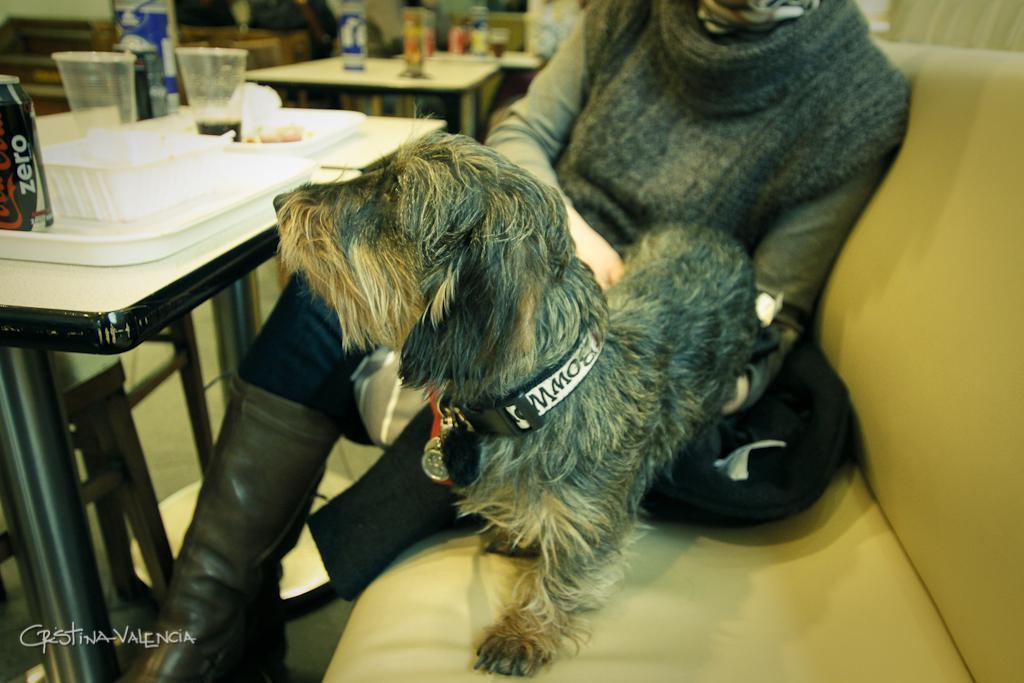Could you give a brief overview of what you see in this image? There is a woman and dog on the sofa which is in brown color. In front of them, there is a tray, glass, and some other food items on the table. In the background, there are some materials on the table, and some other items. 